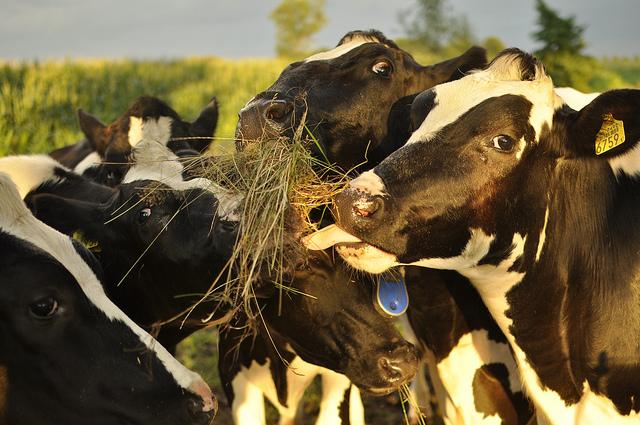Are the cows all the same?
Write a very short answer. Yes. How many cows have their tongue sticking out?
Short answer required. 1. What are the cows eating?
Write a very short answer. Hay. How many cows are in the image?
Quick response, please. 6. 